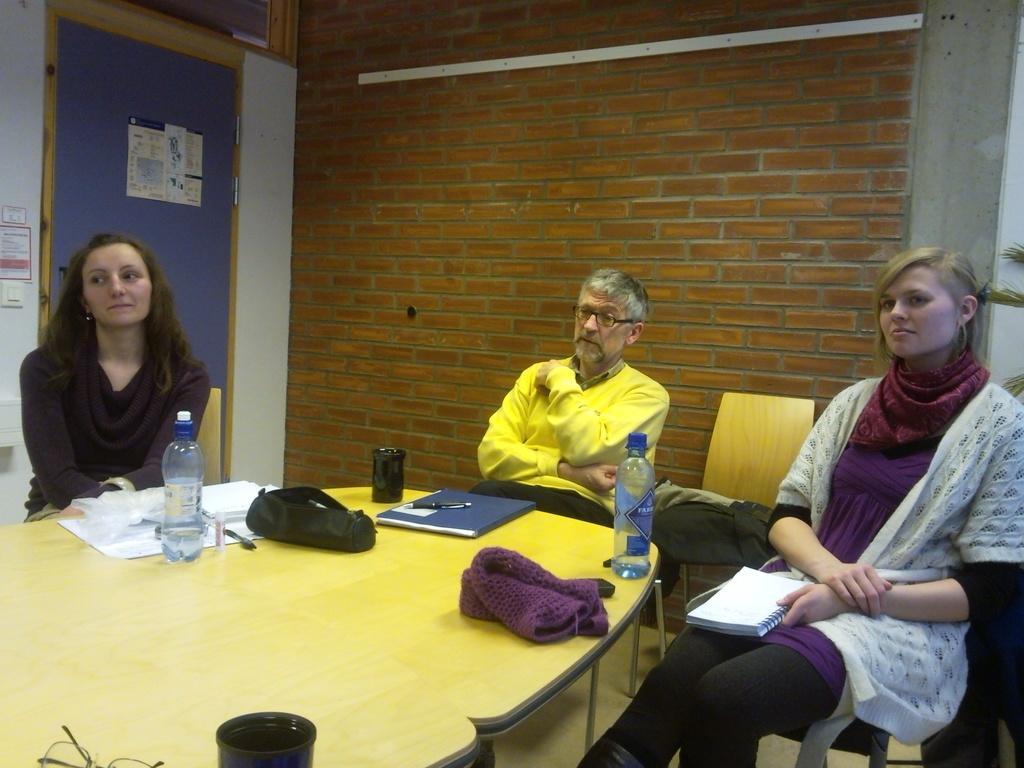Please provide a concise description of this image. In this image I can see three persons are sitting on chairs and in the front of them I can see a table. On the table I can see few bottles, a book, a bag, few glasses, a specs, few pens and few white colour things. On the right side of this image I can see one woman is holding a notebook and behind her I can see a plant. On the the left side I can see few boards and on it I can see something is written. I can also see an empty chair in the background. 